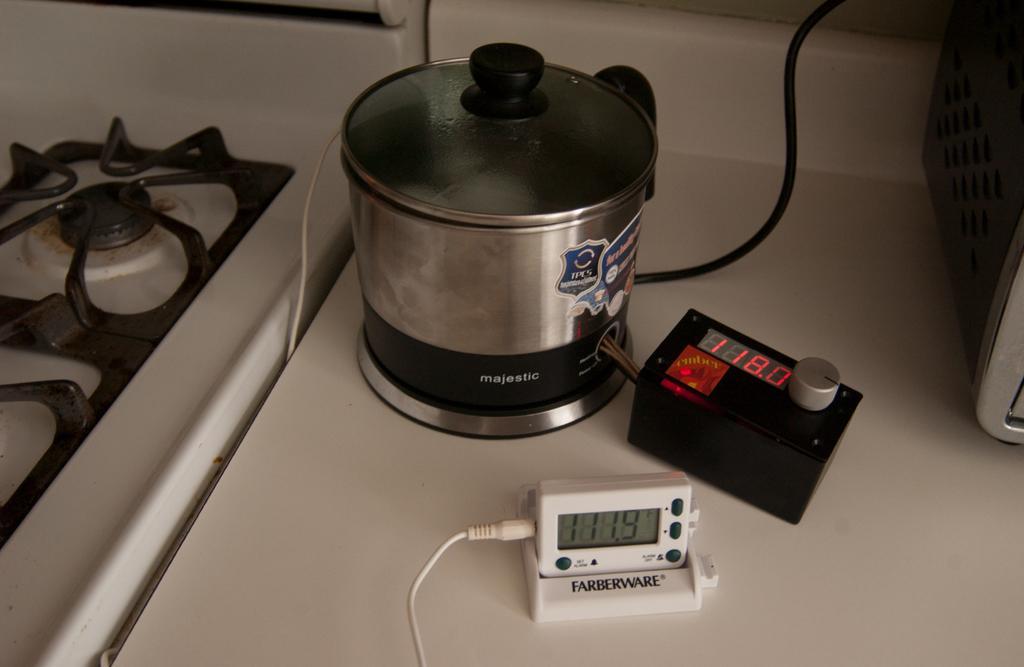Describe this image in one or two sentences. In this image we can see a stove. There are few electrical objects placed on the table. 